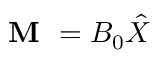<formula> <loc_0><loc_0><loc_500><loc_500>M = B _ { 0 } \hat { X }</formula> 